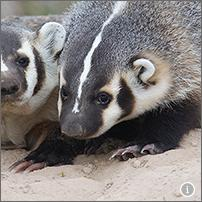Which animal's feet are also adapted for digging? The six-banded armadillo has feet that are well adapted for digging. Like the American badger shown in the image, the six-banded armadillo uses its robust claws to dig into the soil, searching for food such as insects, or to create burrows for shelter. This adaptation is crucial as it allows the armadillo to access underground sources of food and provides a means of escape from predators. Specifically, the armadillo's claws are sturdy and shaped to efficiently move soil, similar to the badger's adaptation. 